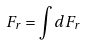<formula> <loc_0><loc_0><loc_500><loc_500>F _ { r } = \int d F _ { r }</formula> 